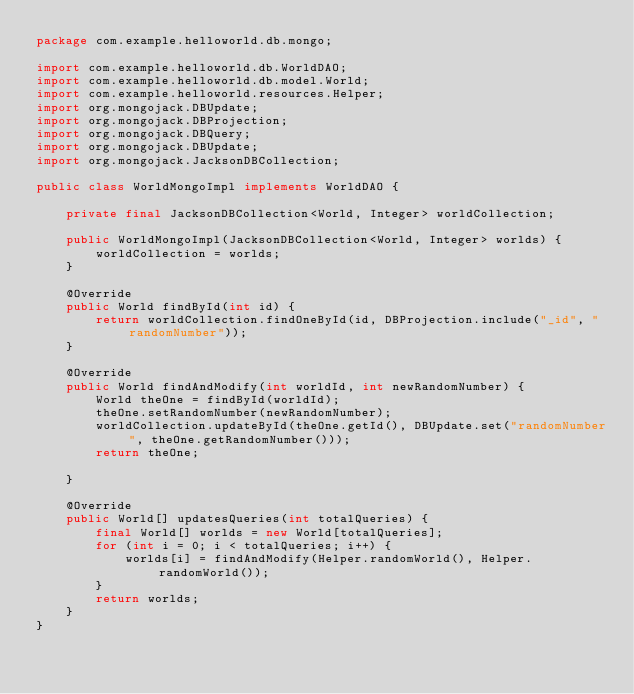Convert code to text. <code><loc_0><loc_0><loc_500><loc_500><_Java_>package com.example.helloworld.db.mongo;

import com.example.helloworld.db.WorldDAO;
import com.example.helloworld.db.model.World;
import com.example.helloworld.resources.Helper;
import org.mongojack.DBUpdate;
import org.mongojack.DBProjection;
import org.mongojack.DBQuery;
import org.mongojack.DBUpdate;
import org.mongojack.JacksonDBCollection;

public class WorldMongoImpl implements WorldDAO {

    private final JacksonDBCollection<World, Integer> worldCollection;

    public WorldMongoImpl(JacksonDBCollection<World, Integer> worlds) {
        worldCollection = worlds;
    }

    @Override
    public World findById(int id) {
        return worldCollection.findOneById(id, DBProjection.include("_id", "randomNumber"));
    }

    @Override
    public World findAndModify(int worldId, int newRandomNumber) {
        World theOne = findById(worldId);
        theOne.setRandomNumber(newRandomNumber);
        worldCollection.updateById(theOne.getId(), DBUpdate.set("randomNumber", theOne.getRandomNumber()));
        return theOne;

    }

    @Override
    public World[] updatesQueries(int totalQueries) {
        final World[] worlds = new World[totalQueries];
        for (int i = 0; i < totalQueries; i++) {
            worlds[i] = findAndModify(Helper.randomWorld(), Helper.randomWorld());
        }
        return worlds;
    }
}
</code> 